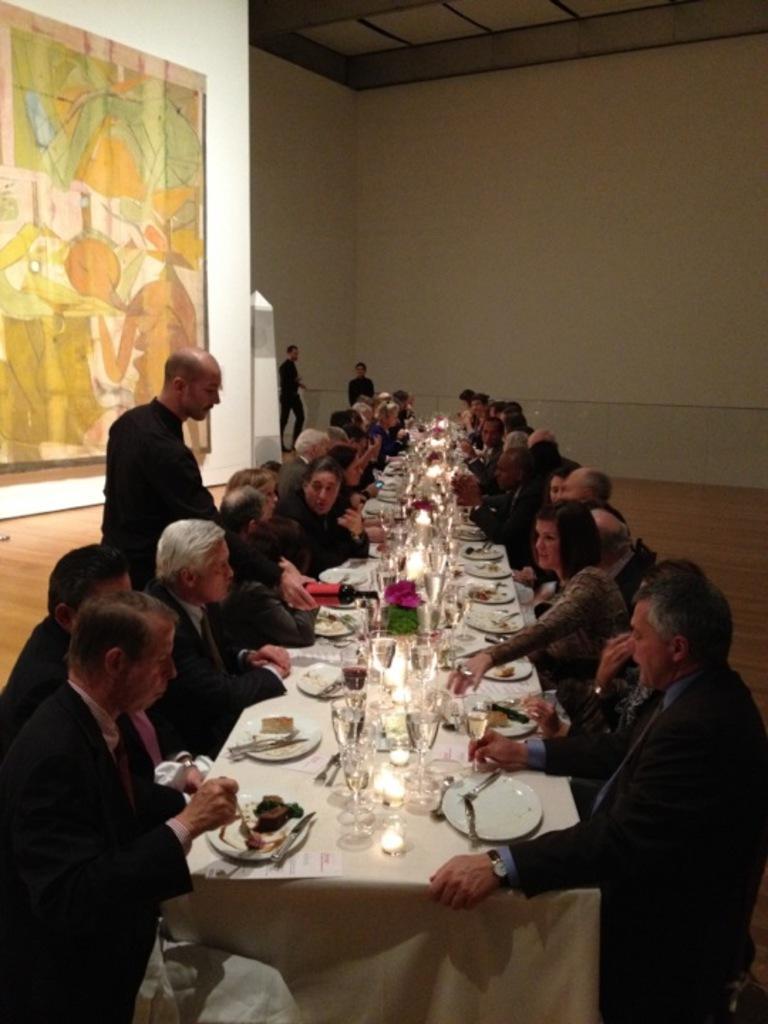Describe this image in one or two sentences. There are group of people sitting in front of a table which has some eatables and drinks on it. 